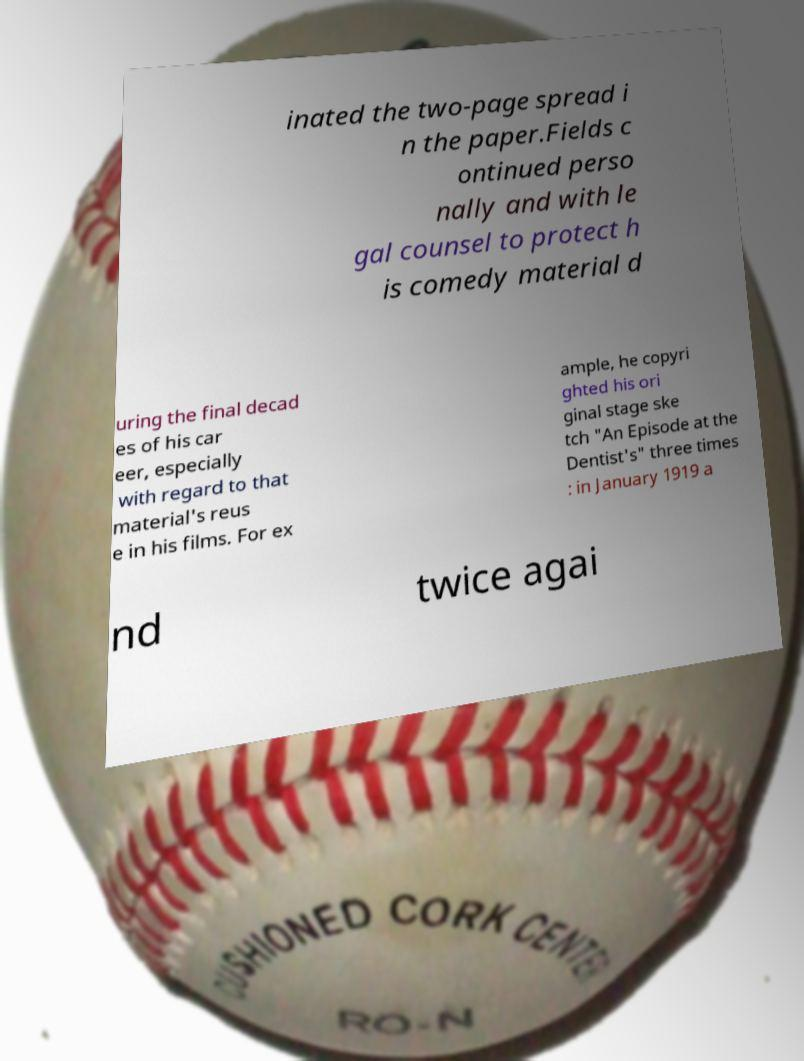Could you assist in decoding the text presented in this image and type it out clearly? inated the two-page spread i n the paper.Fields c ontinued perso nally and with le gal counsel to protect h is comedy material d uring the final decad es of his car eer, especially with regard to that material's reus e in his films. For ex ample, he copyri ghted his ori ginal stage ske tch "An Episode at the Dentist's" three times : in January 1919 a nd twice agai 